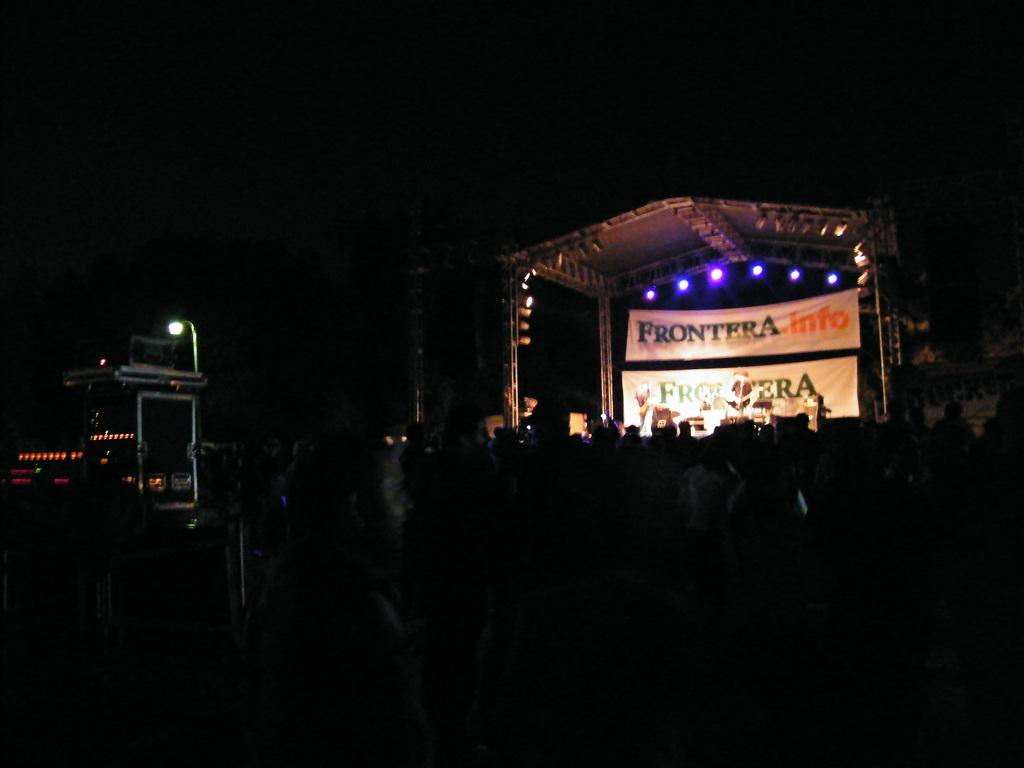How many people are in the image? There is a group of people in the image, but the exact number cannot be determined from the provided facts. What else can be seen in the image besides the people? There are objects and banners present in the image. What is the shed in the image used for? The shed with lights in the image suggests it might be used for an event or gathering. What is the lighting condition in the background of the image? The background of the image has a dark view, indicating that it might be nighttime or in a dimly lit area. What type of pain can be seen on the faces of the people in the image? There is no indication of pain on the faces of the people in the image; they are not depicted as experiencing any discomfort. 